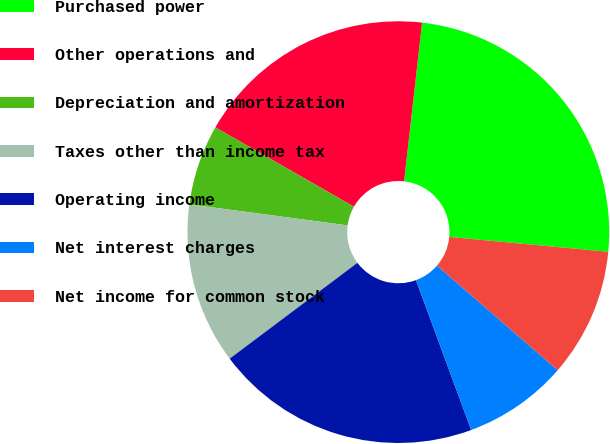<chart> <loc_0><loc_0><loc_500><loc_500><pie_chart><fcel>Purchased power<fcel>Other operations and<fcel>Depreciation and amortization<fcel>Taxes other than income tax<fcel>Operating income<fcel>Net interest charges<fcel>Net income for common stock<nl><fcel>24.69%<fcel>18.52%<fcel>6.17%<fcel>12.35%<fcel>20.37%<fcel>8.02%<fcel>9.88%<nl></chart> 